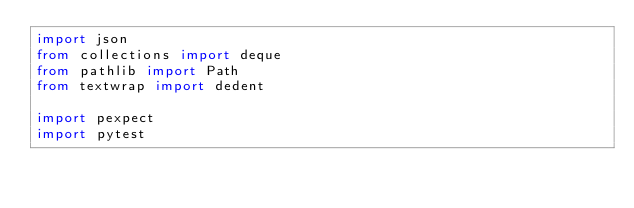<code> <loc_0><loc_0><loc_500><loc_500><_Python_>import json
from collections import deque
from pathlib import Path
from textwrap import dedent

import pexpect
import pytest
</code> 